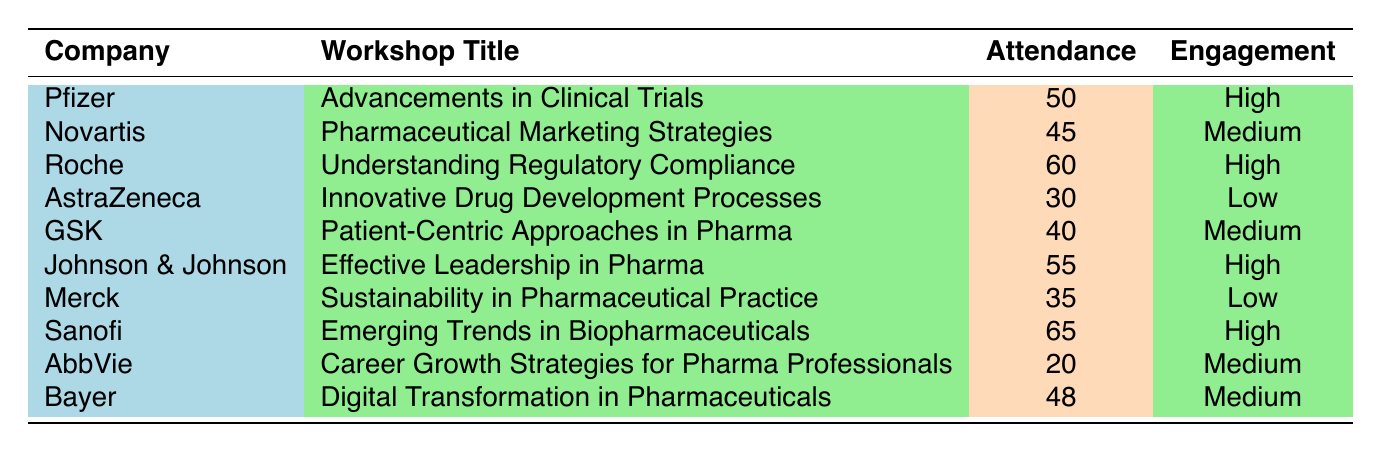What is the attendance for the "Effective Leadership in Pharma" workshop? The table shows that Johnson & Johnson hosted the "Effective Leadership in Pharma" workshop, which had an attendance of 55.
Answer: 55 Which company had the lowest attendance? By examining the attendance figures for each company, AstraZeneca recorded the lowest attendance with 30.
Answer: AstraZeneca How many workshops had a high engagement level? The table lists three companies (Pfizer, Roche, Sanofi, and Johnson & Johnson) that achieved a "High" engagement level across their workshops, so the total is four.
Answer: Four What is the average attendance of all the listed workshops? To find the average, sum the attendances: (50 + 45 + 60 + 30 + 40 + 55 + 35 + 65 + 20 + 48) =  408. Then divide by the number of workshops (10), resulting in 408 / 10 = 40.8.
Answer: 40.8 Is the engagement level for GSK's workshop medium? GSK's workshop on "Patient-Centric Approaches in Pharma" has an engagement level marked as medium according to the table.
Answer: Yes How many companies had an engagement level of low? The table shows two companies, AstraZeneca and Merck, which both have a low engagement level for their workshops, so the total is two.
Answer: Two Which workshop had the highest attendance? The workshop titled "Emerging Trends in Biopharmaceuticals," hosted by Sanofi, had the highest attendance at 65 participants.
Answer: Emerging Trends in Biopharmaceuticals If you compare the engagement levels of AstraZeneca and Merck, how do they differ? Both companies had a low engagement level for their respective workshops, according to the table, indicating that there is no difference in this aspect.
Answer: They are the same (both low) What is the total attendance for workshops with high engagement levels? The attendances for the high engagement workshops are: Pfizer (50), Roche (60), Johnson & Johnson (55), and Sanofi (65). Summing these values gives 50 + 60 + 55 + 65 = 230.
Answer: 230 